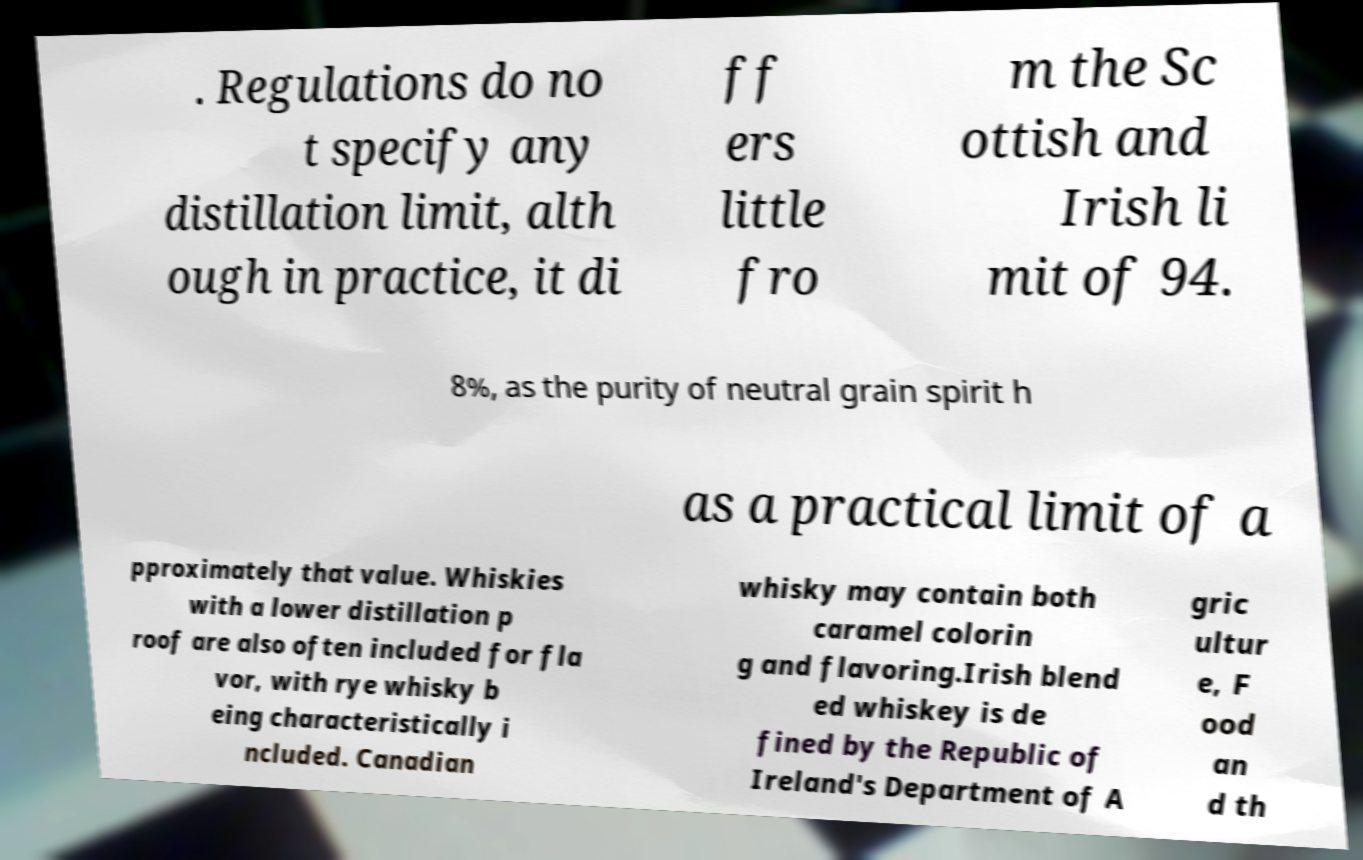What messages or text are displayed in this image? I need them in a readable, typed format. . Regulations do no t specify any distillation limit, alth ough in practice, it di ff ers little fro m the Sc ottish and Irish li mit of 94. 8%, as the purity of neutral grain spirit h as a practical limit of a pproximately that value. Whiskies with a lower distillation p roof are also often included for fla vor, with rye whisky b eing characteristically i ncluded. Canadian whisky may contain both caramel colorin g and flavoring.Irish blend ed whiskey is de fined by the Republic of Ireland's Department of A gric ultur e, F ood an d th 